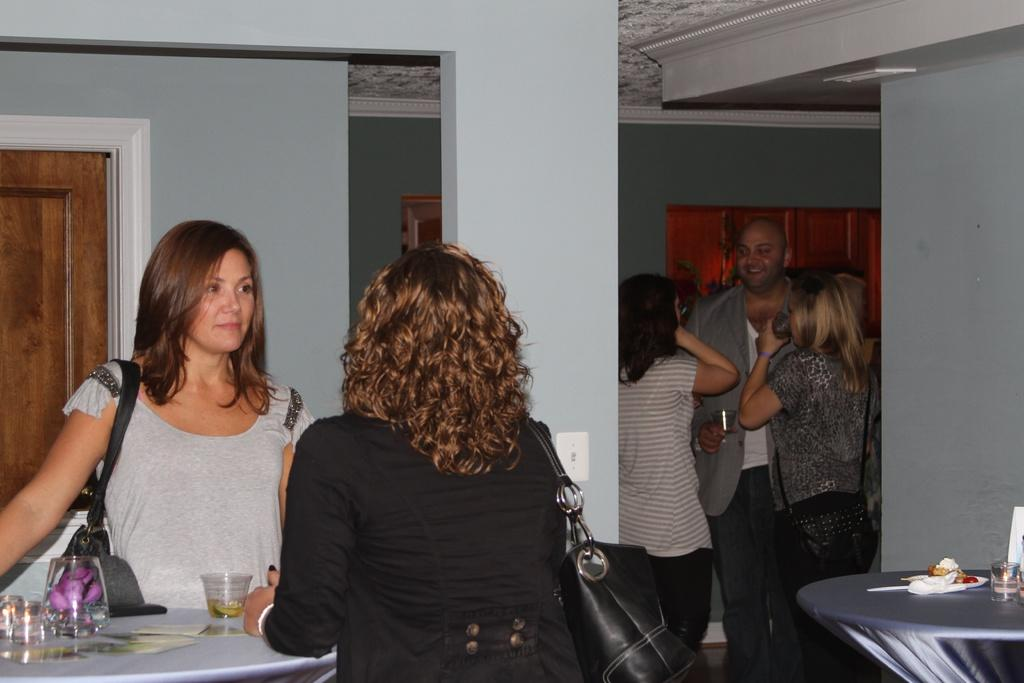What is happening in the foreground of the image? There are people standing near a table. What can be seen in the background of the image? In the background, there are people standing, and a wall is visible. What type of lawyer is standing near the table in the image? There is no lawyer present in the image. How many houses can be seen in the background of the image? There are no houses visible in the image; only a wall is present in the background. 